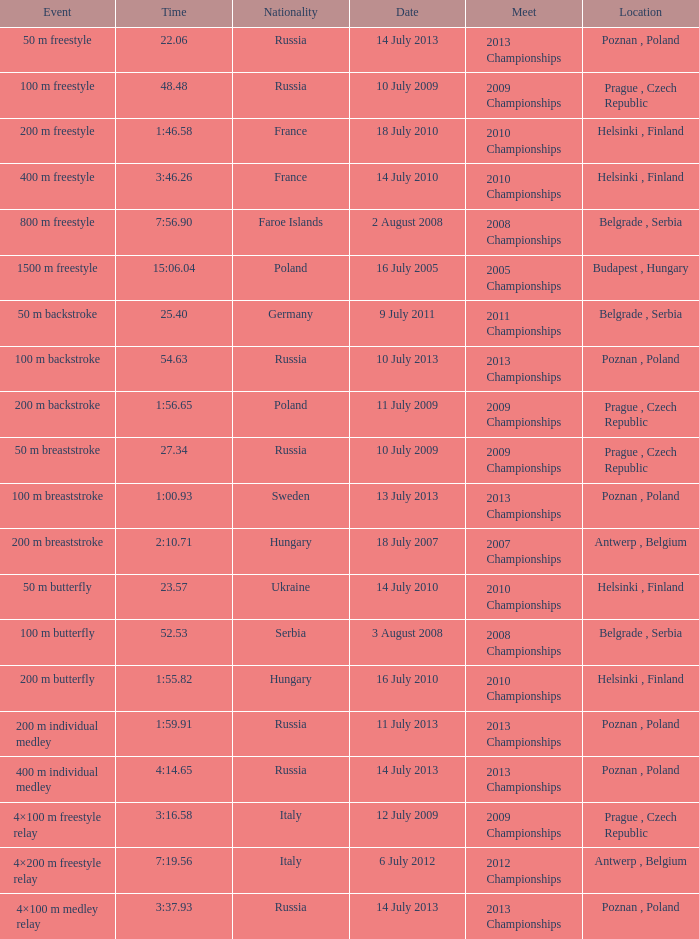On which date did the 1500 m freestyle event occur? 16 July 2005. 